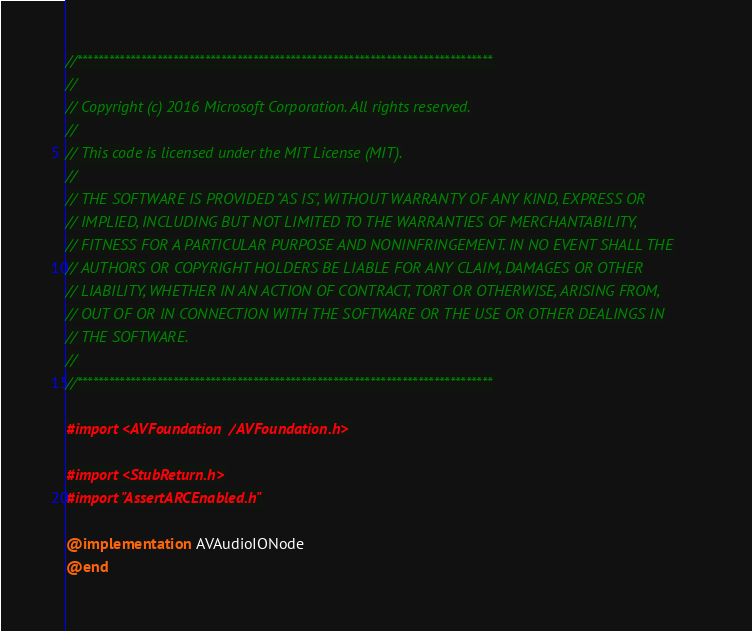<code> <loc_0><loc_0><loc_500><loc_500><_ObjectiveC_>//******************************************************************************
//
// Copyright (c) 2016 Microsoft Corporation. All rights reserved.
//
// This code is licensed under the MIT License (MIT).
//
// THE SOFTWARE IS PROVIDED "AS IS", WITHOUT WARRANTY OF ANY KIND, EXPRESS OR
// IMPLIED, INCLUDING BUT NOT LIMITED TO THE WARRANTIES OF MERCHANTABILITY,
// FITNESS FOR A PARTICULAR PURPOSE AND NONINFRINGEMENT. IN NO EVENT SHALL THE
// AUTHORS OR COPYRIGHT HOLDERS BE LIABLE FOR ANY CLAIM, DAMAGES OR OTHER
// LIABILITY, WHETHER IN AN ACTION OF CONTRACT, TORT OR OTHERWISE, ARISING FROM,
// OUT OF OR IN CONNECTION WITH THE SOFTWARE OR THE USE OR OTHER DEALINGS IN
// THE SOFTWARE.
//
//******************************************************************************

#import <AVFoundation/AVFoundation.h>

#import <StubReturn.h>
#import "AssertARCEnabled.h"

@implementation AVAudioIONode
@end
</code> 